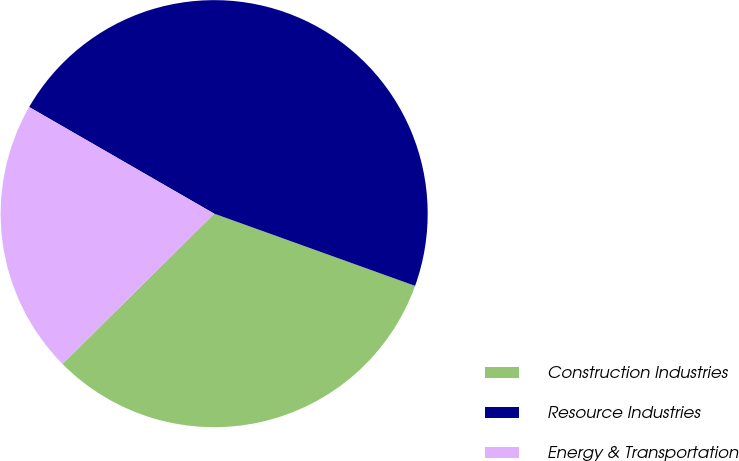Convert chart. <chart><loc_0><loc_0><loc_500><loc_500><pie_chart><fcel>Construction Industries<fcel>Resource Industries<fcel>Energy & Transportation<nl><fcel>32.08%<fcel>47.17%<fcel>20.75%<nl></chart> 